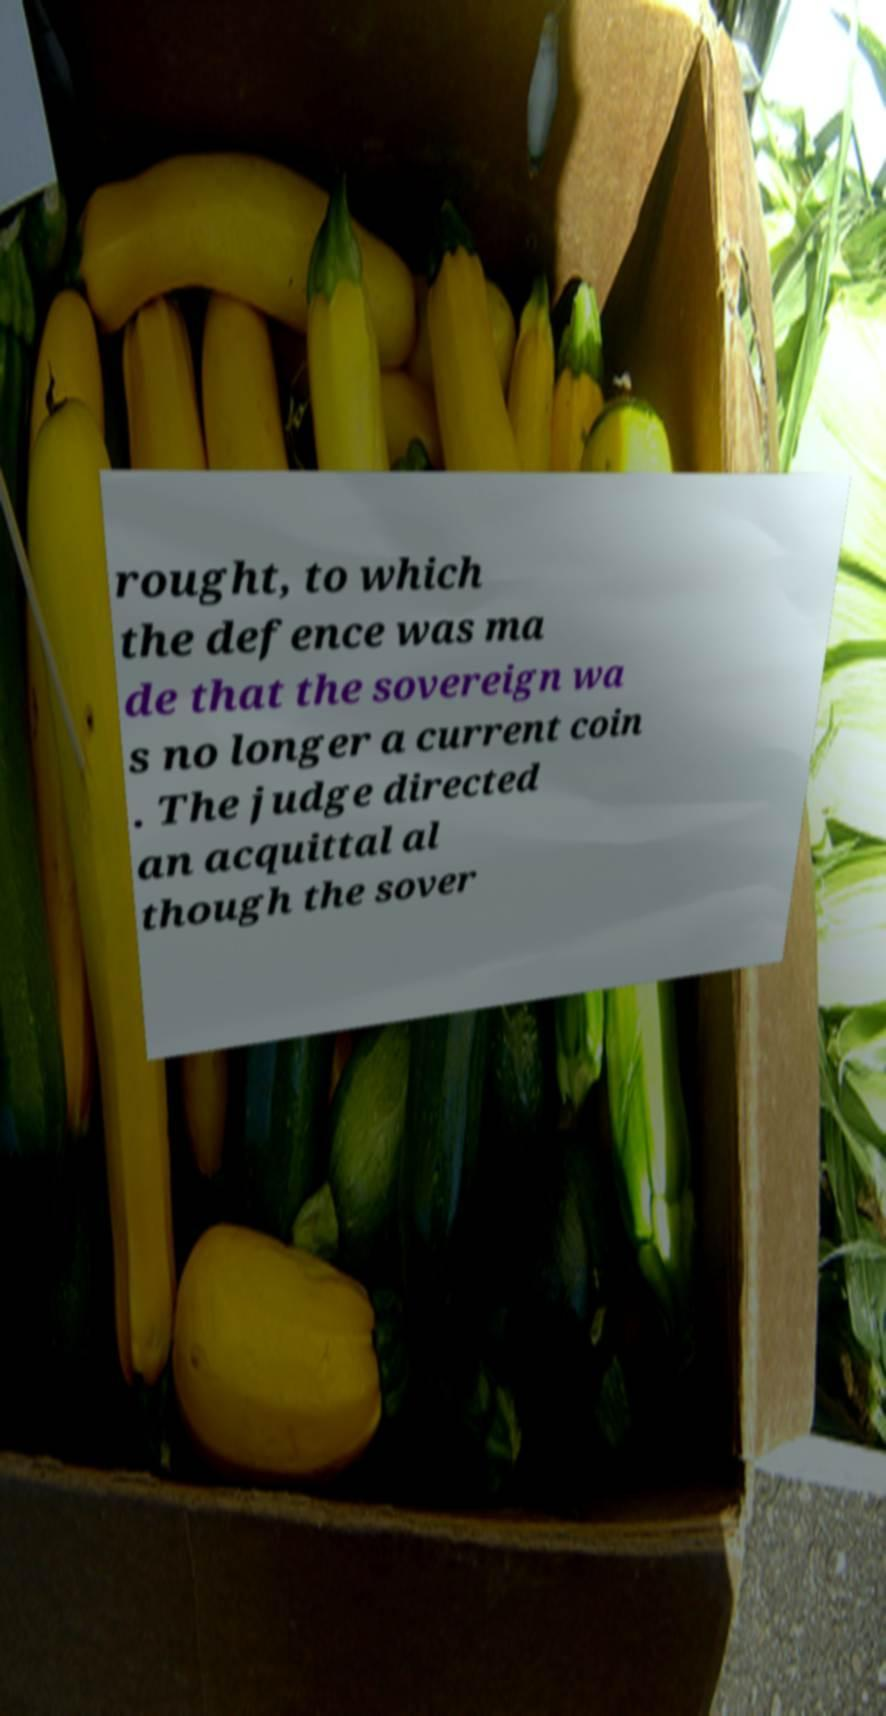Could you extract and type out the text from this image? rought, to which the defence was ma de that the sovereign wa s no longer a current coin . The judge directed an acquittal al though the sover 